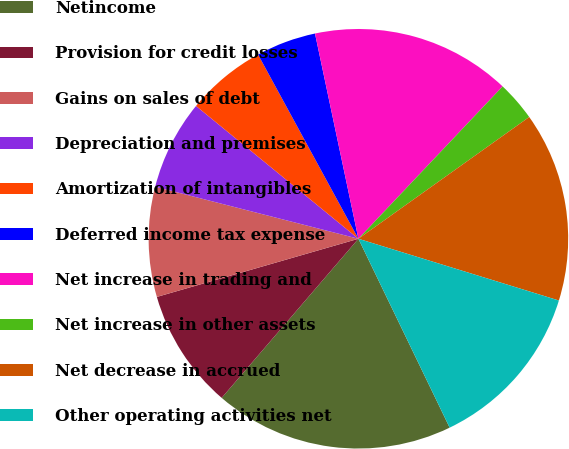Convert chart. <chart><loc_0><loc_0><loc_500><loc_500><pie_chart><fcel>Netincome<fcel>Provision for credit losses<fcel>Gains on sales of debt<fcel>Depreciation and premises<fcel>Amortization of intangibles<fcel>Deferred income tax expense<fcel>Net increase in trading and<fcel>Net increase in other assets<fcel>Net decrease in accrued<fcel>Other operating activities net<nl><fcel>18.46%<fcel>9.23%<fcel>8.46%<fcel>6.92%<fcel>6.15%<fcel>4.62%<fcel>15.38%<fcel>3.08%<fcel>14.61%<fcel>13.08%<nl></chart> 